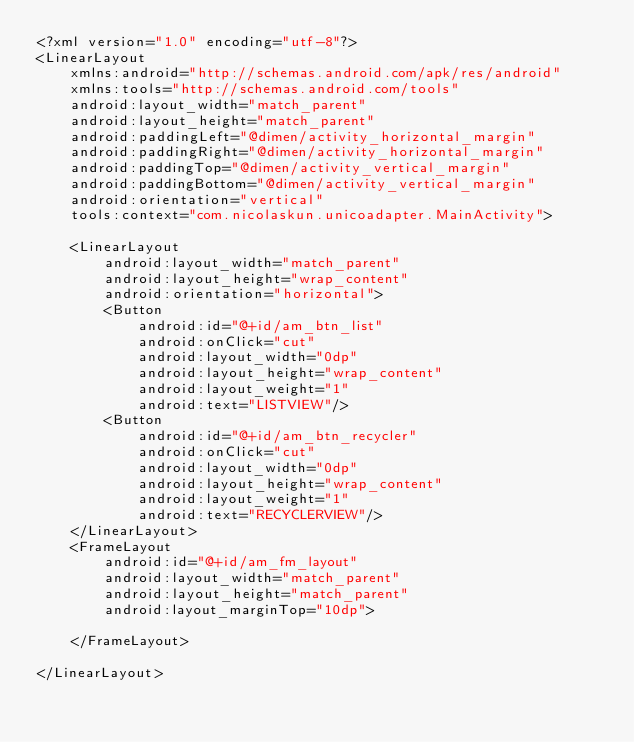Convert code to text. <code><loc_0><loc_0><loc_500><loc_500><_XML_><?xml version="1.0" encoding="utf-8"?>
<LinearLayout
    xmlns:android="http://schemas.android.com/apk/res/android"
    xmlns:tools="http://schemas.android.com/tools"
    android:layout_width="match_parent"
    android:layout_height="match_parent"
    android:paddingLeft="@dimen/activity_horizontal_margin"
    android:paddingRight="@dimen/activity_horizontal_margin"
    android:paddingTop="@dimen/activity_vertical_margin"
    android:paddingBottom="@dimen/activity_vertical_margin"
    android:orientation="vertical"
    tools:context="com.nicolaskun.unicoadapter.MainActivity">

    <LinearLayout
        android:layout_width="match_parent"
        android:layout_height="wrap_content"
        android:orientation="horizontal">
        <Button
            android:id="@+id/am_btn_list"
            android:onClick="cut"
            android:layout_width="0dp"
            android:layout_height="wrap_content"
            android:layout_weight="1"
            android:text="LISTVIEW"/>
        <Button
            android:id="@+id/am_btn_recycler"
            android:onClick="cut"
            android:layout_width="0dp"
            android:layout_height="wrap_content"
            android:layout_weight="1"
            android:text="RECYCLERVIEW"/>
    </LinearLayout>
    <FrameLayout
        android:id="@+id/am_fm_layout"
        android:layout_width="match_parent"
        android:layout_height="match_parent"
        android:layout_marginTop="10dp">

    </FrameLayout>

</LinearLayout>
</code> 